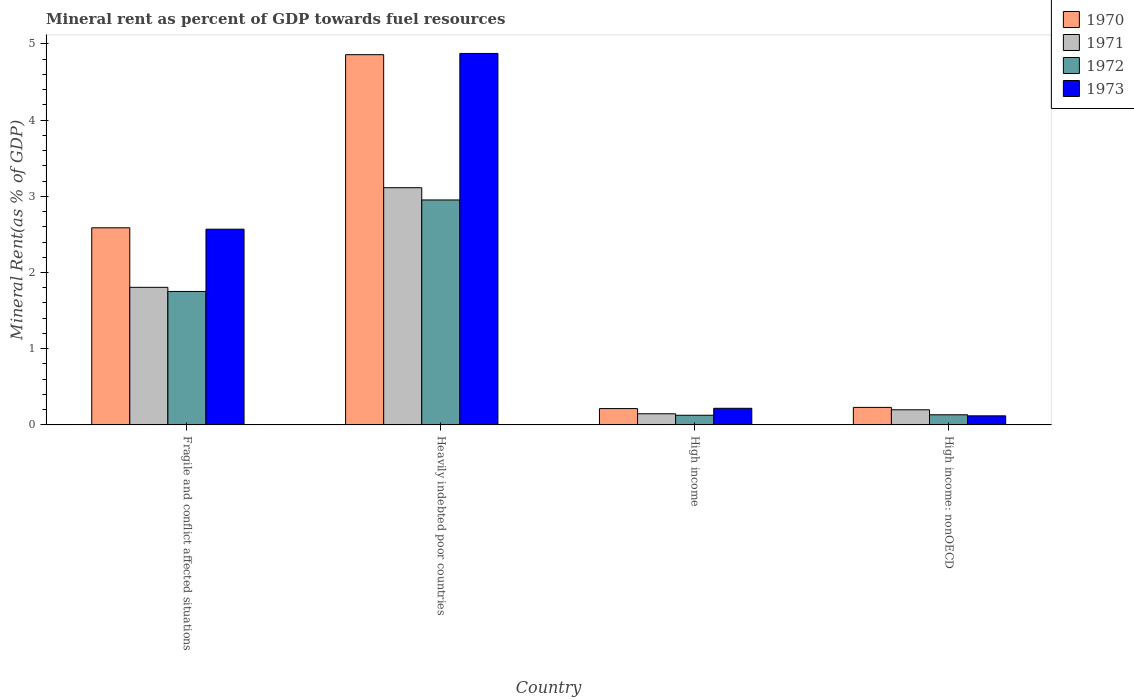How many different coloured bars are there?
Offer a very short reply. 4. How many groups of bars are there?
Provide a succinct answer. 4. Are the number of bars on each tick of the X-axis equal?
Provide a short and direct response. Yes. How many bars are there on the 3rd tick from the left?
Ensure brevity in your answer.  4. How many bars are there on the 3rd tick from the right?
Your answer should be very brief. 4. What is the label of the 2nd group of bars from the left?
Your response must be concise. Heavily indebted poor countries. In how many cases, is the number of bars for a given country not equal to the number of legend labels?
Give a very brief answer. 0. What is the mineral rent in 1970 in Fragile and conflict affected situations?
Offer a terse response. 2.59. Across all countries, what is the maximum mineral rent in 1973?
Make the answer very short. 4.87. Across all countries, what is the minimum mineral rent in 1970?
Offer a very short reply. 0.21. In which country was the mineral rent in 1973 maximum?
Ensure brevity in your answer.  Heavily indebted poor countries. What is the total mineral rent in 1973 in the graph?
Your answer should be very brief. 7.78. What is the difference between the mineral rent in 1973 in Heavily indebted poor countries and that in High income: nonOECD?
Provide a succinct answer. 4.75. What is the difference between the mineral rent in 1973 in High income: nonOECD and the mineral rent in 1970 in Heavily indebted poor countries?
Give a very brief answer. -4.74. What is the average mineral rent in 1970 per country?
Your answer should be compact. 1.97. What is the difference between the mineral rent of/in 1970 and mineral rent of/in 1972 in Fragile and conflict affected situations?
Give a very brief answer. 0.84. What is the ratio of the mineral rent in 1973 in Fragile and conflict affected situations to that in Heavily indebted poor countries?
Make the answer very short. 0.53. Is the mineral rent in 1972 in Heavily indebted poor countries less than that in High income: nonOECD?
Your answer should be compact. No. What is the difference between the highest and the second highest mineral rent in 1973?
Provide a succinct answer. -2.35. What is the difference between the highest and the lowest mineral rent in 1971?
Give a very brief answer. 2.97. In how many countries, is the mineral rent in 1973 greater than the average mineral rent in 1973 taken over all countries?
Give a very brief answer. 2. Is the sum of the mineral rent in 1970 in Heavily indebted poor countries and High income: nonOECD greater than the maximum mineral rent in 1973 across all countries?
Offer a very short reply. Yes. Is it the case that in every country, the sum of the mineral rent in 1970 and mineral rent in 1973 is greater than the sum of mineral rent in 1972 and mineral rent in 1971?
Your answer should be compact. No. What does the 3rd bar from the left in High income: nonOECD represents?
Your response must be concise. 1972. What does the 1st bar from the right in High income represents?
Give a very brief answer. 1973. Is it the case that in every country, the sum of the mineral rent in 1970 and mineral rent in 1971 is greater than the mineral rent in 1973?
Give a very brief answer. Yes. What is the difference between two consecutive major ticks on the Y-axis?
Your response must be concise. 1. Does the graph contain any zero values?
Your response must be concise. No. How many legend labels are there?
Make the answer very short. 4. What is the title of the graph?
Keep it short and to the point. Mineral rent as percent of GDP towards fuel resources. What is the label or title of the Y-axis?
Ensure brevity in your answer.  Mineral Rent(as % of GDP). What is the Mineral Rent(as % of GDP) in 1970 in Fragile and conflict affected situations?
Make the answer very short. 2.59. What is the Mineral Rent(as % of GDP) of 1971 in Fragile and conflict affected situations?
Offer a very short reply. 1.81. What is the Mineral Rent(as % of GDP) in 1972 in Fragile and conflict affected situations?
Keep it short and to the point. 1.75. What is the Mineral Rent(as % of GDP) of 1973 in Fragile and conflict affected situations?
Offer a terse response. 2.57. What is the Mineral Rent(as % of GDP) in 1970 in Heavily indebted poor countries?
Ensure brevity in your answer.  4.86. What is the Mineral Rent(as % of GDP) of 1971 in Heavily indebted poor countries?
Give a very brief answer. 3.11. What is the Mineral Rent(as % of GDP) in 1972 in Heavily indebted poor countries?
Ensure brevity in your answer.  2.95. What is the Mineral Rent(as % of GDP) of 1973 in Heavily indebted poor countries?
Your answer should be compact. 4.87. What is the Mineral Rent(as % of GDP) in 1970 in High income?
Ensure brevity in your answer.  0.21. What is the Mineral Rent(as % of GDP) of 1971 in High income?
Offer a terse response. 0.15. What is the Mineral Rent(as % of GDP) of 1972 in High income?
Offer a terse response. 0.13. What is the Mineral Rent(as % of GDP) of 1973 in High income?
Provide a short and direct response. 0.22. What is the Mineral Rent(as % of GDP) of 1970 in High income: nonOECD?
Provide a succinct answer. 0.23. What is the Mineral Rent(as % of GDP) of 1971 in High income: nonOECD?
Offer a terse response. 0.2. What is the Mineral Rent(as % of GDP) of 1972 in High income: nonOECD?
Give a very brief answer. 0.13. What is the Mineral Rent(as % of GDP) in 1973 in High income: nonOECD?
Make the answer very short. 0.12. Across all countries, what is the maximum Mineral Rent(as % of GDP) in 1970?
Offer a very short reply. 4.86. Across all countries, what is the maximum Mineral Rent(as % of GDP) in 1971?
Make the answer very short. 3.11. Across all countries, what is the maximum Mineral Rent(as % of GDP) in 1972?
Ensure brevity in your answer.  2.95. Across all countries, what is the maximum Mineral Rent(as % of GDP) in 1973?
Provide a succinct answer. 4.87. Across all countries, what is the minimum Mineral Rent(as % of GDP) of 1970?
Offer a very short reply. 0.21. Across all countries, what is the minimum Mineral Rent(as % of GDP) in 1971?
Your answer should be compact. 0.15. Across all countries, what is the minimum Mineral Rent(as % of GDP) in 1972?
Make the answer very short. 0.13. Across all countries, what is the minimum Mineral Rent(as % of GDP) in 1973?
Offer a very short reply. 0.12. What is the total Mineral Rent(as % of GDP) of 1970 in the graph?
Make the answer very short. 7.89. What is the total Mineral Rent(as % of GDP) of 1971 in the graph?
Your answer should be very brief. 5.26. What is the total Mineral Rent(as % of GDP) in 1972 in the graph?
Provide a short and direct response. 4.96. What is the total Mineral Rent(as % of GDP) in 1973 in the graph?
Your answer should be compact. 7.78. What is the difference between the Mineral Rent(as % of GDP) in 1970 in Fragile and conflict affected situations and that in Heavily indebted poor countries?
Keep it short and to the point. -2.27. What is the difference between the Mineral Rent(as % of GDP) in 1971 in Fragile and conflict affected situations and that in Heavily indebted poor countries?
Your answer should be very brief. -1.31. What is the difference between the Mineral Rent(as % of GDP) of 1972 in Fragile and conflict affected situations and that in Heavily indebted poor countries?
Your answer should be compact. -1.2. What is the difference between the Mineral Rent(as % of GDP) in 1973 in Fragile and conflict affected situations and that in Heavily indebted poor countries?
Offer a terse response. -2.31. What is the difference between the Mineral Rent(as % of GDP) of 1970 in Fragile and conflict affected situations and that in High income?
Offer a terse response. 2.37. What is the difference between the Mineral Rent(as % of GDP) in 1971 in Fragile and conflict affected situations and that in High income?
Offer a very short reply. 1.66. What is the difference between the Mineral Rent(as % of GDP) of 1972 in Fragile and conflict affected situations and that in High income?
Keep it short and to the point. 1.62. What is the difference between the Mineral Rent(as % of GDP) in 1973 in Fragile and conflict affected situations and that in High income?
Ensure brevity in your answer.  2.35. What is the difference between the Mineral Rent(as % of GDP) in 1970 in Fragile and conflict affected situations and that in High income: nonOECD?
Make the answer very short. 2.36. What is the difference between the Mineral Rent(as % of GDP) of 1971 in Fragile and conflict affected situations and that in High income: nonOECD?
Your answer should be compact. 1.61. What is the difference between the Mineral Rent(as % of GDP) in 1972 in Fragile and conflict affected situations and that in High income: nonOECD?
Your response must be concise. 1.62. What is the difference between the Mineral Rent(as % of GDP) of 1973 in Fragile and conflict affected situations and that in High income: nonOECD?
Your answer should be compact. 2.45. What is the difference between the Mineral Rent(as % of GDP) of 1970 in Heavily indebted poor countries and that in High income?
Your answer should be compact. 4.64. What is the difference between the Mineral Rent(as % of GDP) in 1971 in Heavily indebted poor countries and that in High income?
Keep it short and to the point. 2.97. What is the difference between the Mineral Rent(as % of GDP) of 1972 in Heavily indebted poor countries and that in High income?
Provide a succinct answer. 2.82. What is the difference between the Mineral Rent(as % of GDP) in 1973 in Heavily indebted poor countries and that in High income?
Your response must be concise. 4.66. What is the difference between the Mineral Rent(as % of GDP) of 1970 in Heavily indebted poor countries and that in High income: nonOECD?
Your answer should be very brief. 4.63. What is the difference between the Mineral Rent(as % of GDP) of 1971 in Heavily indebted poor countries and that in High income: nonOECD?
Offer a terse response. 2.91. What is the difference between the Mineral Rent(as % of GDP) of 1972 in Heavily indebted poor countries and that in High income: nonOECD?
Provide a short and direct response. 2.82. What is the difference between the Mineral Rent(as % of GDP) in 1973 in Heavily indebted poor countries and that in High income: nonOECD?
Your response must be concise. 4.75. What is the difference between the Mineral Rent(as % of GDP) in 1970 in High income and that in High income: nonOECD?
Provide a succinct answer. -0.02. What is the difference between the Mineral Rent(as % of GDP) in 1971 in High income and that in High income: nonOECD?
Your answer should be compact. -0.05. What is the difference between the Mineral Rent(as % of GDP) in 1972 in High income and that in High income: nonOECD?
Your response must be concise. -0.01. What is the difference between the Mineral Rent(as % of GDP) of 1973 in High income and that in High income: nonOECD?
Provide a succinct answer. 0.1. What is the difference between the Mineral Rent(as % of GDP) of 1970 in Fragile and conflict affected situations and the Mineral Rent(as % of GDP) of 1971 in Heavily indebted poor countries?
Offer a very short reply. -0.53. What is the difference between the Mineral Rent(as % of GDP) in 1970 in Fragile and conflict affected situations and the Mineral Rent(as % of GDP) in 1972 in Heavily indebted poor countries?
Ensure brevity in your answer.  -0.37. What is the difference between the Mineral Rent(as % of GDP) in 1970 in Fragile and conflict affected situations and the Mineral Rent(as % of GDP) in 1973 in Heavily indebted poor countries?
Your response must be concise. -2.29. What is the difference between the Mineral Rent(as % of GDP) in 1971 in Fragile and conflict affected situations and the Mineral Rent(as % of GDP) in 1972 in Heavily indebted poor countries?
Make the answer very short. -1.15. What is the difference between the Mineral Rent(as % of GDP) in 1971 in Fragile and conflict affected situations and the Mineral Rent(as % of GDP) in 1973 in Heavily indebted poor countries?
Your response must be concise. -3.07. What is the difference between the Mineral Rent(as % of GDP) in 1972 in Fragile and conflict affected situations and the Mineral Rent(as % of GDP) in 1973 in Heavily indebted poor countries?
Your response must be concise. -3.12. What is the difference between the Mineral Rent(as % of GDP) of 1970 in Fragile and conflict affected situations and the Mineral Rent(as % of GDP) of 1971 in High income?
Offer a terse response. 2.44. What is the difference between the Mineral Rent(as % of GDP) in 1970 in Fragile and conflict affected situations and the Mineral Rent(as % of GDP) in 1972 in High income?
Your response must be concise. 2.46. What is the difference between the Mineral Rent(as % of GDP) in 1970 in Fragile and conflict affected situations and the Mineral Rent(as % of GDP) in 1973 in High income?
Give a very brief answer. 2.37. What is the difference between the Mineral Rent(as % of GDP) of 1971 in Fragile and conflict affected situations and the Mineral Rent(as % of GDP) of 1972 in High income?
Provide a short and direct response. 1.68. What is the difference between the Mineral Rent(as % of GDP) in 1971 in Fragile and conflict affected situations and the Mineral Rent(as % of GDP) in 1973 in High income?
Your response must be concise. 1.59. What is the difference between the Mineral Rent(as % of GDP) in 1972 in Fragile and conflict affected situations and the Mineral Rent(as % of GDP) in 1973 in High income?
Your answer should be compact. 1.53. What is the difference between the Mineral Rent(as % of GDP) of 1970 in Fragile and conflict affected situations and the Mineral Rent(as % of GDP) of 1971 in High income: nonOECD?
Ensure brevity in your answer.  2.39. What is the difference between the Mineral Rent(as % of GDP) of 1970 in Fragile and conflict affected situations and the Mineral Rent(as % of GDP) of 1972 in High income: nonOECD?
Offer a terse response. 2.45. What is the difference between the Mineral Rent(as % of GDP) in 1970 in Fragile and conflict affected situations and the Mineral Rent(as % of GDP) in 1973 in High income: nonOECD?
Give a very brief answer. 2.47. What is the difference between the Mineral Rent(as % of GDP) in 1971 in Fragile and conflict affected situations and the Mineral Rent(as % of GDP) in 1972 in High income: nonOECD?
Provide a succinct answer. 1.67. What is the difference between the Mineral Rent(as % of GDP) in 1971 in Fragile and conflict affected situations and the Mineral Rent(as % of GDP) in 1973 in High income: nonOECD?
Keep it short and to the point. 1.69. What is the difference between the Mineral Rent(as % of GDP) in 1972 in Fragile and conflict affected situations and the Mineral Rent(as % of GDP) in 1973 in High income: nonOECD?
Provide a short and direct response. 1.63. What is the difference between the Mineral Rent(as % of GDP) in 1970 in Heavily indebted poor countries and the Mineral Rent(as % of GDP) in 1971 in High income?
Provide a short and direct response. 4.71. What is the difference between the Mineral Rent(as % of GDP) in 1970 in Heavily indebted poor countries and the Mineral Rent(as % of GDP) in 1972 in High income?
Offer a terse response. 4.73. What is the difference between the Mineral Rent(as % of GDP) of 1970 in Heavily indebted poor countries and the Mineral Rent(as % of GDP) of 1973 in High income?
Give a very brief answer. 4.64. What is the difference between the Mineral Rent(as % of GDP) of 1971 in Heavily indebted poor countries and the Mineral Rent(as % of GDP) of 1972 in High income?
Ensure brevity in your answer.  2.99. What is the difference between the Mineral Rent(as % of GDP) of 1971 in Heavily indebted poor countries and the Mineral Rent(as % of GDP) of 1973 in High income?
Give a very brief answer. 2.89. What is the difference between the Mineral Rent(as % of GDP) of 1972 in Heavily indebted poor countries and the Mineral Rent(as % of GDP) of 1973 in High income?
Offer a terse response. 2.73. What is the difference between the Mineral Rent(as % of GDP) in 1970 in Heavily indebted poor countries and the Mineral Rent(as % of GDP) in 1971 in High income: nonOECD?
Provide a short and direct response. 4.66. What is the difference between the Mineral Rent(as % of GDP) in 1970 in Heavily indebted poor countries and the Mineral Rent(as % of GDP) in 1972 in High income: nonOECD?
Provide a succinct answer. 4.72. What is the difference between the Mineral Rent(as % of GDP) in 1970 in Heavily indebted poor countries and the Mineral Rent(as % of GDP) in 1973 in High income: nonOECD?
Ensure brevity in your answer.  4.74. What is the difference between the Mineral Rent(as % of GDP) in 1971 in Heavily indebted poor countries and the Mineral Rent(as % of GDP) in 1972 in High income: nonOECD?
Offer a very short reply. 2.98. What is the difference between the Mineral Rent(as % of GDP) in 1971 in Heavily indebted poor countries and the Mineral Rent(as % of GDP) in 1973 in High income: nonOECD?
Give a very brief answer. 2.99. What is the difference between the Mineral Rent(as % of GDP) in 1972 in Heavily indebted poor countries and the Mineral Rent(as % of GDP) in 1973 in High income: nonOECD?
Your answer should be compact. 2.83. What is the difference between the Mineral Rent(as % of GDP) of 1970 in High income and the Mineral Rent(as % of GDP) of 1971 in High income: nonOECD?
Offer a very short reply. 0.02. What is the difference between the Mineral Rent(as % of GDP) in 1970 in High income and the Mineral Rent(as % of GDP) in 1972 in High income: nonOECD?
Offer a very short reply. 0.08. What is the difference between the Mineral Rent(as % of GDP) of 1970 in High income and the Mineral Rent(as % of GDP) of 1973 in High income: nonOECD?
Offer a terse response. 0.1. What is the difference between the Mineral Rent(as % of GDP) in 1971 in High income and the Mineral Rent(as % of GDP) in 1972 in High income: nonOECD?
Your answer should be compact. 0.01. What is the difference between the Mineral Rent(as % of GDP) of 1971 in High income and the Mineral Rent(as % of GDP) of 1973 in High income: nonOECD?
Ensure brevity in your answer.  0.03. What is the difference between the Mineral Rent(as % of GDP) in 1972 in High income and the Mineral Rent(as % of GDP) in 1973 in High income: nonOECD?
Give a very brief answer. 0.01. What is the average Mineral Rent(as % of GDP) of 1970 per country?
Your answer should be compact. 1.97. What is the average Mineral Rent(as % of GDP) in 1971 per country?
Provide a short and direct response. 1.32. What is the average Mineral Rent(as % of GDP) in 1972 per country?
Provide a short and direct response. 1.24. What is the average Mineral Rent(as % of GDP) in 1973 per country?
Offer a very short reply. 1.94. What is the difference between the Mineral Rent(as % of GDP) in 1970 and Mineral Rent(as % of GDP) in 1971 in Fragile and conflict affected situations?
Make the answer very short. 0.78. What is the difference between the Mineral Rent(as % of GDP) of 1970 and Mineral Rent(as % of GDP) of 1972 in Fragile and conflict affected situations?
Your answer should be very brief. 0.84. What is the difference between the Mineral Rent(as % of GDP) of 1970 and Mineral Rent(as % of GDP) of 1973 in Fragile and conflict affected situations?
Ensure brevity in your answer.  0.02. What is the difference between the Mineral Rent(as % of GDP) in 1971 and Mineral Rent(as % of GDP) in 1972 in Fragile and conflict affected situations?
Keep it short and to the point. 0.05. What is the difference between the Mineral Rent(as % of GDP) in 1971 and Mineral Rent(as % of GDP) in 1973 in Fragile and conflict affected situations?
Your answer should be very brief. -0.76. What is the difference between the Mineral Rent(as % of GDP) in 1972 and Mineral Rent(as % of GDP) in 1973 in Fragile and conflict affected situations?
Provide a succinct answer. -0.82. What is the difference between the Mineral Rent(as % of GDP) of 1970 and Mineral Rent(as % of GDP) of 1971 in Heavily indebted poor countries?
Offer a very short reply. 1.75. What is the difference between the Mineral Rent(as % of GDP) in 1970 and Mineral Rent(as % of GDP) in 1972 in Heavily indebted poor countries?
Your answer should be very brief. 1.91. What is the difference between the Mineral Rent(as % of GDP) of 1970 and Mineral Rent(as % of GDP) of 1973 in Heavily indebted poor countries?
Provide a short and direct response. -0.02. What is the difference between the Mineral Rent(as % of GDP) of 1971 and Mineral Rent(as % of GDP) of 1972 in Heavily indebted poor countries?
Provide a succinct answer. 0.16. What is the difference between the Mineral Rent(as % of GDP) of 1971 and Mineral Rent(as % of GDP) of 1973 in Heavily indebted poor countries?
Offer a terse response. -1.76. What is the difference between the Mineral Rent(as % of GDP) in 1972 and Mineral Rent(as % of GDP) in 1973 in Heavily indebted poor countries?
Your response must be concise. -1.92. What is the difference between the Mineral Rent(as % of GDP) in 1970 and Mineral Rent(as % of GDP) in 1971 in High income?
Provide a succinct answer. 0.07. What is the difference between the Mineral Rent(as % of GDP) of 1970 and Mineral Rent(as % of GDP) of 1972 in High income?
Provide a short and direct response. 0.09. What is the difference between the Mineral Rent(as % of GDP) in 1970 and Mineral Rent(as % of GDP) in 1973 in High income?
Your answer should be compact. -0. What is the difference between the Mineral Rent(as % of GDP) of 1971 and Mineral Rent(as % of GDP) of 1972 in High income?
Give a very brief answer. 0.02. What is the difference between the Mineral Rent(as % of GDP) of 1971 and Mineral Rent(as % of GDP) of 1973 in High income?
Your response must be concise. -0.07. What is the difference between the Mineral Rent(as % of GDP) in 1972 and Mineral Rent(as % of GDP) in 1973 in High income?
Give a very brief answer. -0.09. What is the difference between the Mineral Rent(as % of GDP) in 1970 and Mineral Rent(as % of GDP) in 1971 in High income: nonOECD?
Make the answer very short. 0.03. What is the difference between the Mineral Rent(as % of GDP) in 1970 and Mineral Rent(as % of GDP) in 1972 in High income: nonOECD?
Your answer should be very brief. 0.1. What is the difference between the Mineral Rent(as % of GDP) of 1970 and Mineral Rent(as % of GDP) of 1973 in High income: nonOECD?
Provide a succinct answer. 0.11. What is the difference between the Mineral Rent(as % of GDP) of 1971 and Mineral Rent(as % of GDP) of 1972 in High income: nonOECD?
Your answer should be compact. 0.07. What is the difference between the Mineral Rent(as % of GDP) in 1971 and Mineral Rent(as % of GDP) in 1973 in High income: nonOECD?
Ensure brevity in your answer.  0.08. What is the difference between the Mineral Rent(as % of GDP) of 1972 and Mineral Rent(as % of GDP) of 1973 in High income: nonOECD?
Ensure brevity in your answer.  0.01. What is the ratio of the Mineral Rent(as % of GDP) of 1970 in Fragile and conflict affected situations to that in Heavily indebted poor countries?
Give a very brief answer. 0.53. What is the ratio of the Mineral Rent(as % of GDP) of 1971 in Fragile and conflict affected situations to that in Heavily indebted poor countries?
Provide a short and direct response. 0.58. What is the ratio of the Mineral Rent(as % of GDP) of 1972 in Fragile and conflict affected situations to that in Heavily indebted poor countries?
Offer a very short reply. 0.59. What is the ratio of the Mineral Rent(as % of GDP) of 1973 in Fragile and conflict affected situations to that in Heavily indebted poor countries?
Provide a short and direct response. 0.53. What is the ratio of the Mineral Rent(as % of GDP) of 1970 in Fragile and conflict affected situations to that in High income?
Provide a short and direct response. 12.08. What is the ratio of the Mineral Rent(as % of GDP) in 1971 in Fragile and conflict affected situations to that in High income?
Your response must be concise. 12.36. What is the ratio of the Mineral Rent(as % of GDP) of 1972 in Fragile and conflict affected situations to that in High income?
Give a very brief answer. 13.82. What is the ratio of the Mineral Rent(as % of GDP) in 1973 in Fragile and conflict affected situations to that in High income?
Your answer should be very brief. 11.78. What is the ratio of the Mineral Rent(as % of GDP) of 1970 in Fragile and conflict affected situations to that in High income: nonOECD?
Provide a succinct answer. 11.26. What is the ratio of the Mineral Rent(as % of GDP) in 1971 in Fragile and conflict affected situations to that in High income: nonOECD?
Provide a succinct answer. 9.09. What is the ratio of the Mineral Rent(as % of GDP) of 1972 in Fragile and conflict affected situations to that in High income: nonOECD?
Offer a terse response. 13.15. What is the ratio of the Mineral Rent(as % of GDP) in 1973 in Fragile and conflict affected situations to that in High income: nonOECD?
Keep it short and to the point. 21.58. What is the ratio of the Mineral Rent(as % of GDP) in 1970 in Heavily indebted poor countries to that in High income?
Keep it short and to the point. 22.69. What is the ratio of the Mineral Rent(as % of GDP) in 1971 in Heavily indebted poor countries to that in High income?
Offer a very short reply. 21.31. What is the ratio of the Mineral Rent(as % of GDP) of 1972 in Heavily indebted poor countries to that in High income?
Offer a terse response. 23.3. What is the ratio of the Mineral Rent(as % of GDP) of 1973 in Heavily indebted poor countries to that in High income?
Give a very brief answer. 22.35. What is the ratio of the Mineral Rent(as % of GDP) in 1970 in Heavily indebted poor countries to that in High income: nonOECD?
Give a very brief answer. 21.14. What is the ratio of the Mineral Rent(as % of GDP) in 1971 in Heavily indebted poor countries to that in High income: nonOECD?
Provide a short and direct response. 15.68. What is the ratio of the Mineral Rent(as % of GDP) in 1972 in Heavily indebted poor countries to that in High income: nonOECD?
Offer a terse response. 22.17. What is the ratio of the Mineral Rent(as % of GDP) of 1973 in Heavily indebted poor countries to that in High income: nonOECD?
Your answer should be compact. 40.95. What is the ratio of the Mineral Rent(as % of GDP) of 1970 in High income to that in High income: nonOECD?
Your response must be concise. 0.93. What is the ratio of the Mineral Rent(as % of GDP) in 1971 in High income to that in High income: nonOECD?
Ensure brevity in your answer.  0.74. What is the ratio of the Mineral Rent(as % of GDP) in 1972 in High income to that in High income: nonOECD?
Your answer should be very brief. 0.95. What is the ratio of the Mineral Rent(as % of GDP) of 1973 in High income to that in High income: nonOECD?
Your answer should be very brief. 1.83. What is the difference between the highest and the second highest Mineral Rent(as % of GDP) in 1970?
Your response must be concise. 2.27. What is the difference between the highest and the second highest Mineral Rent(as % of GDP) in 1971?
Offer a very short reply. 1.31. What is the difference between the highest and the second highest Mineral Rent(as % of GDP) in 1972?
Keep it short and to the point. 1.2. What is the difference between the highest and the second highest Mineral Rent(as % of GDP) in 1973?
Offer a terse response. 2.31. What is the difference between the highest and the lowest Mineral Rent(as % of GDP) of 1970?
Offer a terse response. 4.64. What is the difference between the highest and the lowest Mineral Rent(as % of GDP) of 1971?
Provide a short and direct response. 2.97. What is the difference between the highest and the lowest Mineral Rent(as % of GDP) of 1972?
Provide a succinct answer. 2.82. What is the difference between the highest and the lowest Mineral Rent(as % of GDP) in 1973?
Make the answer very short. 4.75. 